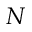<formula> <loc_0><loc_0><loc_500><loc_500>N</formula> 